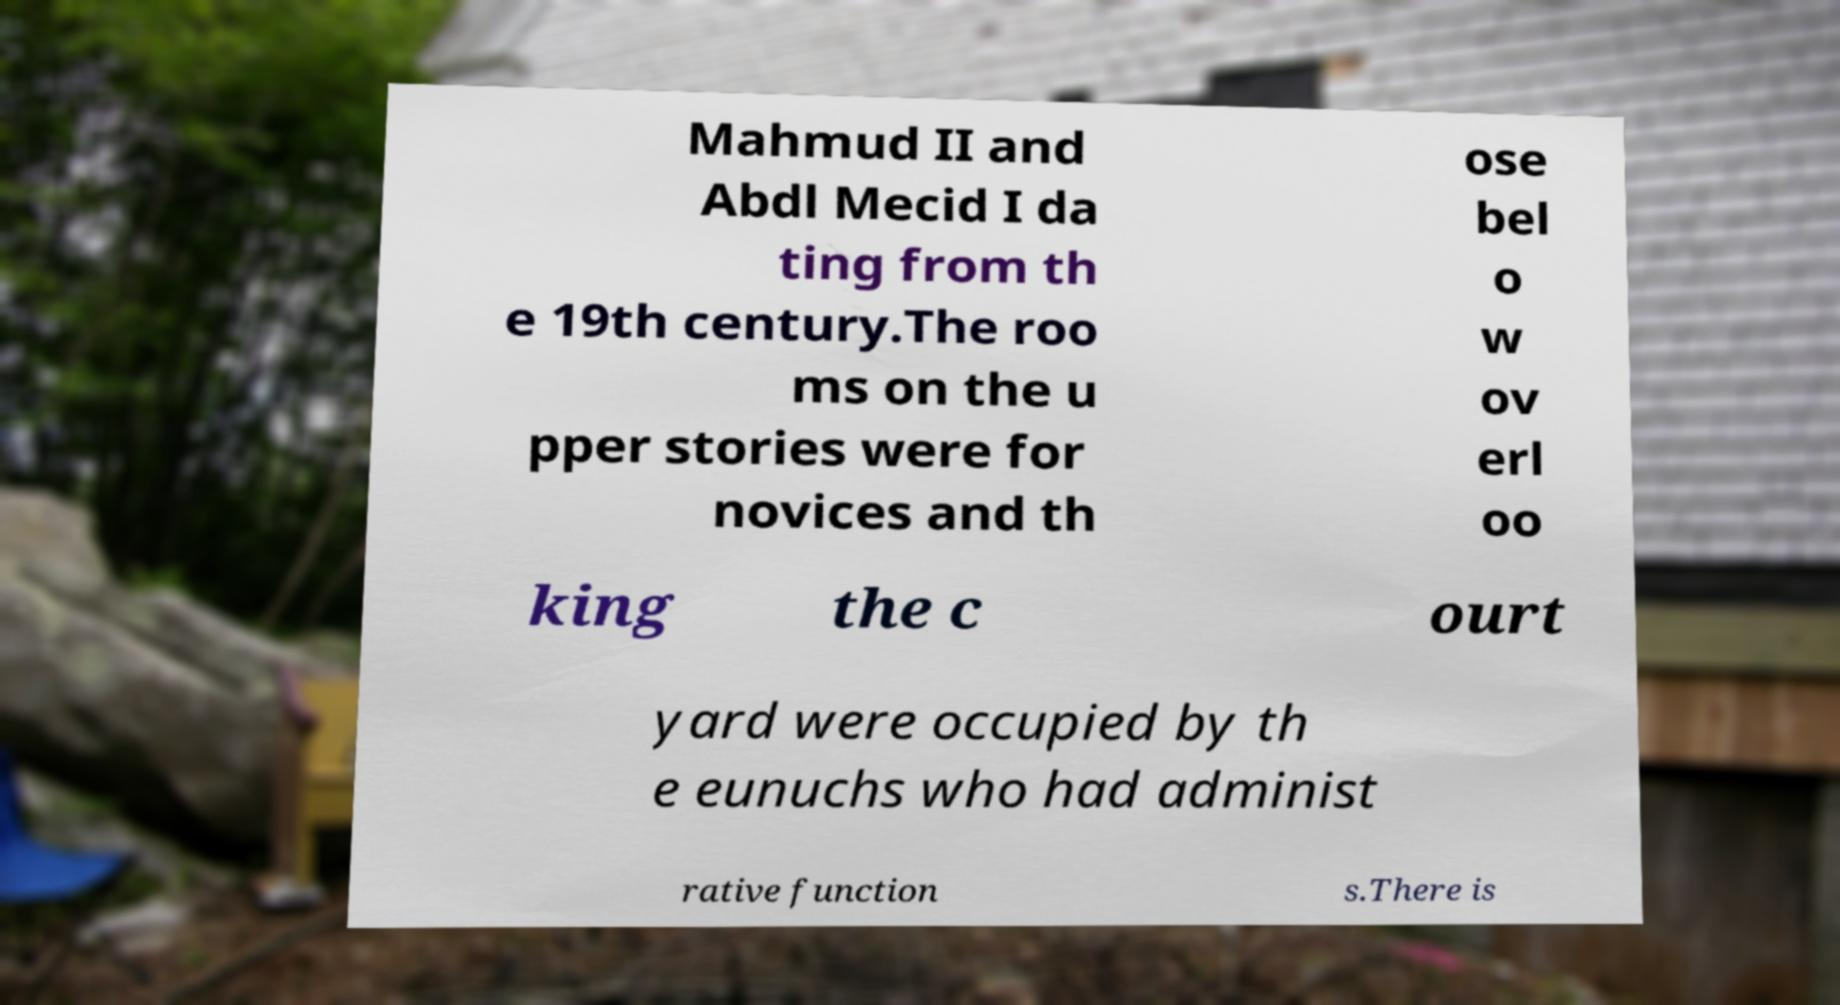I need the written content from this picture converted into text. Can you do that? Mahmud II and Abdl Mecid I da ting from th e 19th century.The roo ms on the u pper stories were for novices and th ose bel o w ov erl oo king the c ourt yard were occupied by th e eunuchs who had administ rative function s.There is 